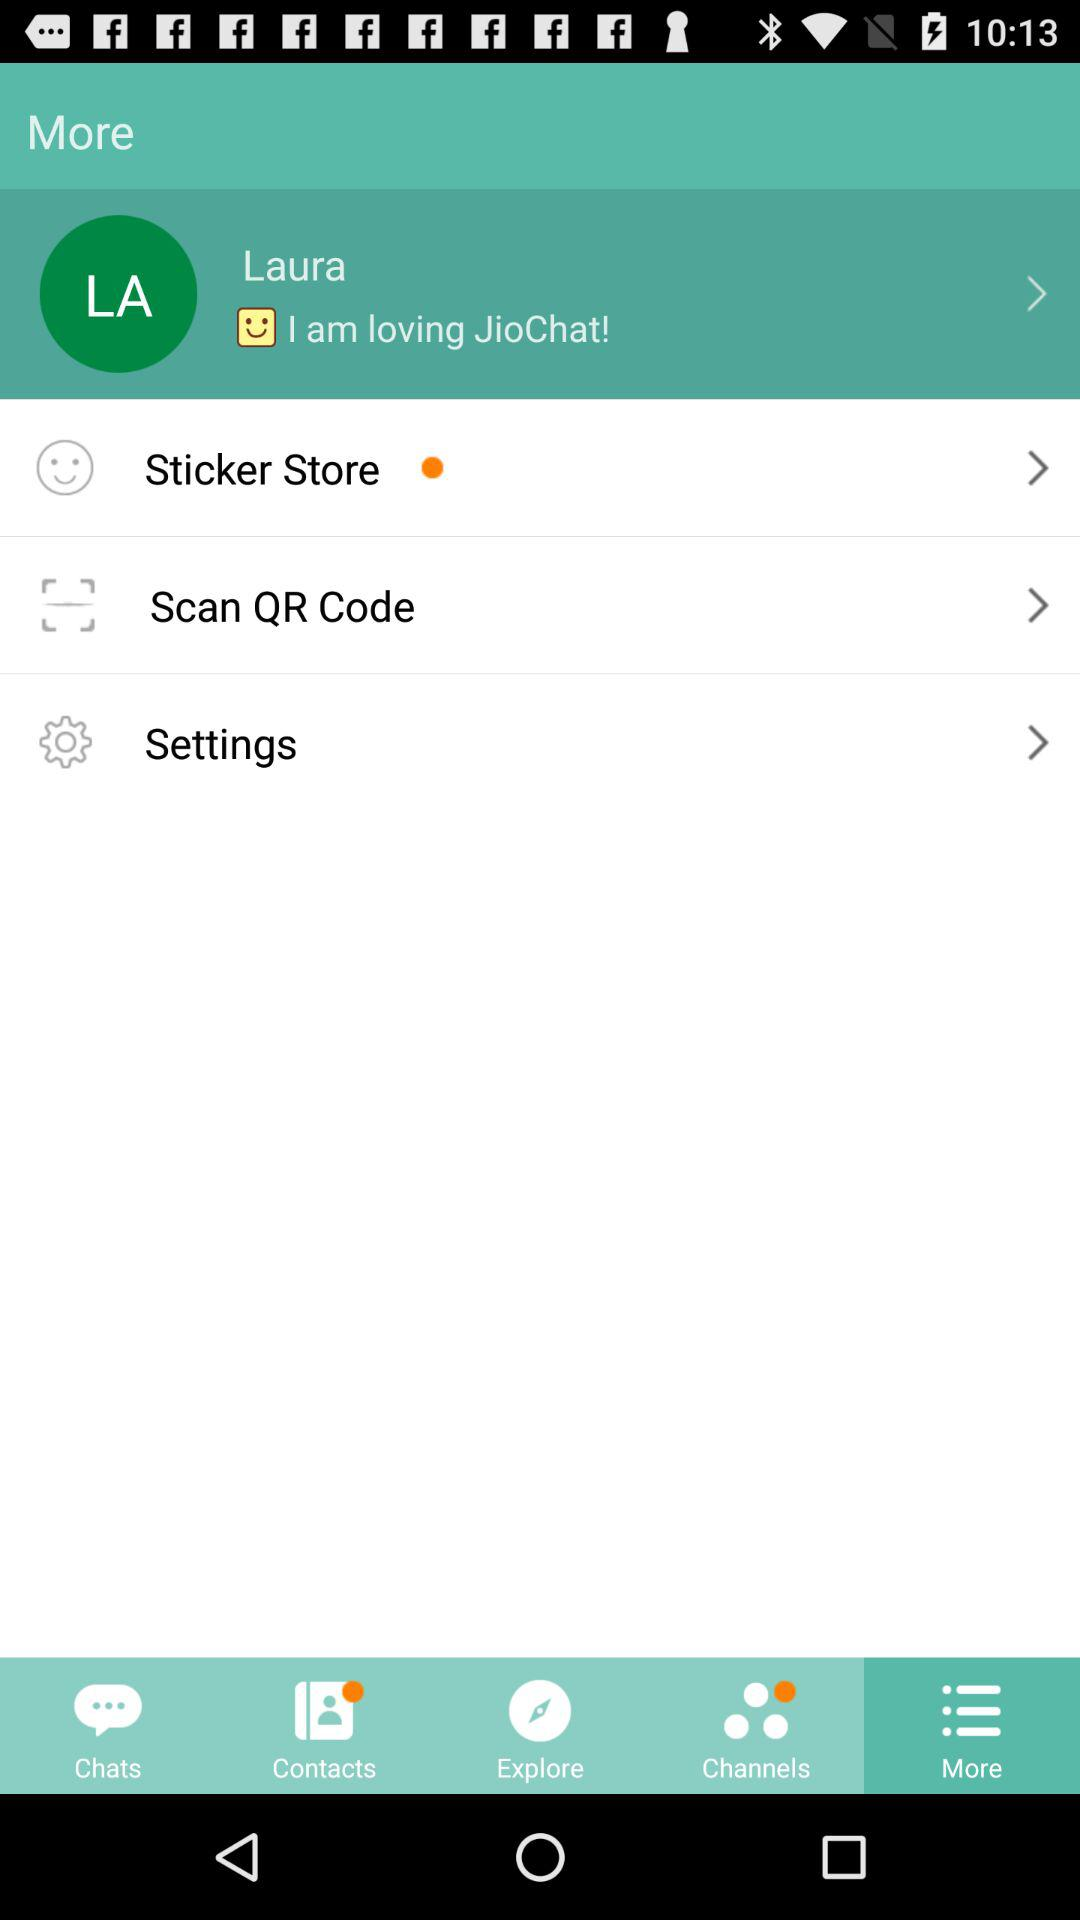What is the status posted by Laura? The status posted by Laura is "I am loving JioChat!". 